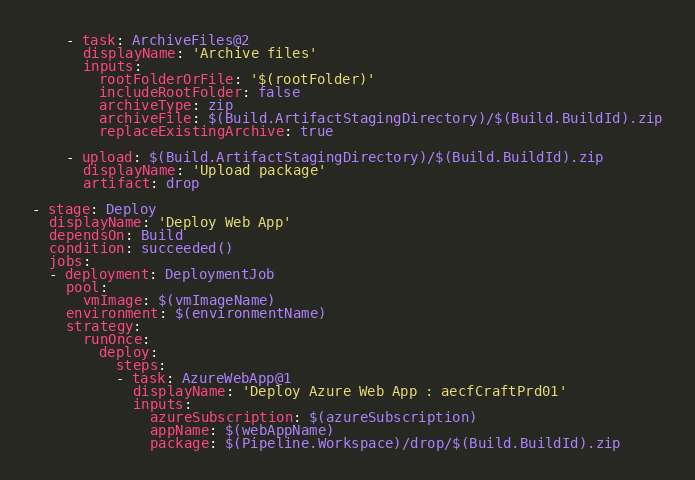<code> <loc_0><loc_0><loc_500><loc_500><_YAML_>
    - task: ArchiveFiles@2
      displayName: 'Archive files'
      inputs:
        rootFolderOrFile: '$(rootFolder)'
        includeRootFolder: false
        archiveType: zip
        archiveFile: $(Build.ArtifactStagingDirectory)/$(Build.BuildId).zip
        replaceExistingArchive: true
    
    - upload: $(Build.ArtifactStagingDirectory)/$(Build.BuildId).zip
      displayName: 'Upload package'
      artifact: drop

- stage: Deploy
  displayName: 'Deploy Web App'
  dependsOn: Build
  condition: succeeded()
  jobs:
  - deployment: DeploymentJob
    pool:
      vmImage: $(vmImageName)
    environment: $(environmentName)
    strategy:
      runOnce:
        deploy:
          steps:
          - task: AzureWebApp@1
            displayName: 'Deploy Azure Web App : aecfCraftPrd01'
            inputs:
              azureSubscription: $(azureSubscription)
              appName: $(webAppName)
              package: $(Pipeline.Workspace)/drop/$(Build.BuildId).zip</code> 